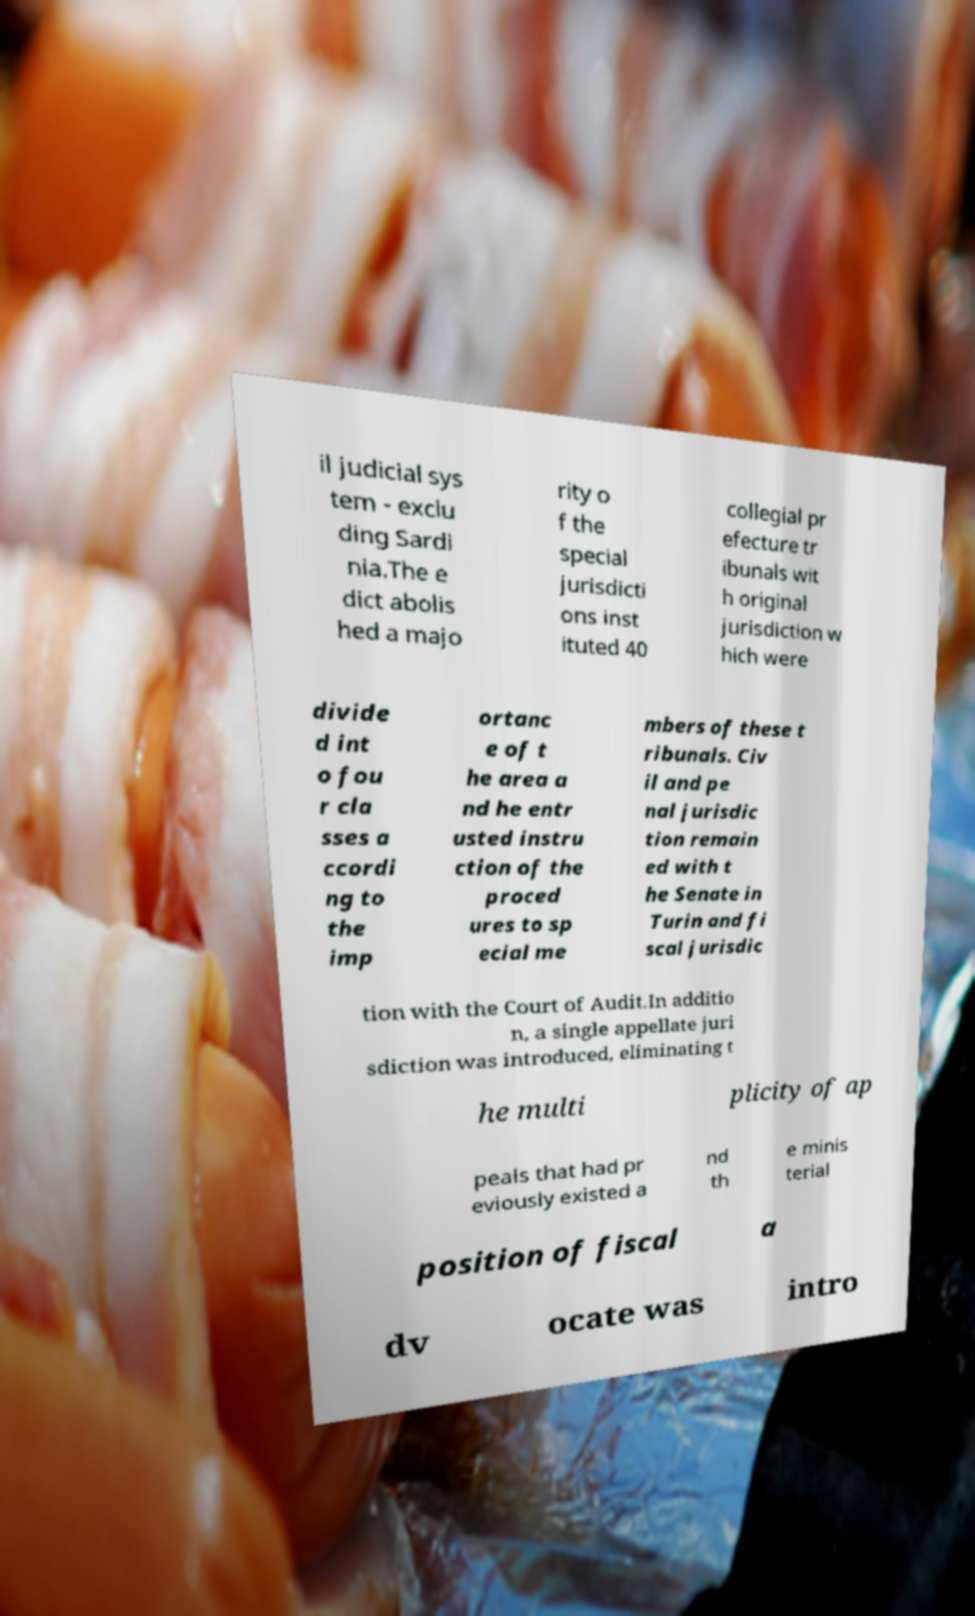For documentation purposes, I need the text within this image transcribed. Could you provide that? il judicial sys tem - exclu ding Sardi nia.The e dict abolis hed a majo rity o f the special jurisdicti ons inst ituted 40 collegial pr efecture tr ibunals wit h original jurisdiction w hich were divide d int o fou r cla sses a ccordi ng to the imp ortanc e of t he area a nd he entr usted instru ction of the proced ures to sp ecial me mbers of these t ribunals. Civ il and pe nal jurisdic tion remain ed with t he Senate in Turin and fi scal jurisdic tion with the Court of Audit.In additio n, a single appellate juri sdiction was introduced, eliminating t he multi plicity of ap peals that had pr eviously existed a nd th e minis terial position of fiscal a dv ocate was intro 